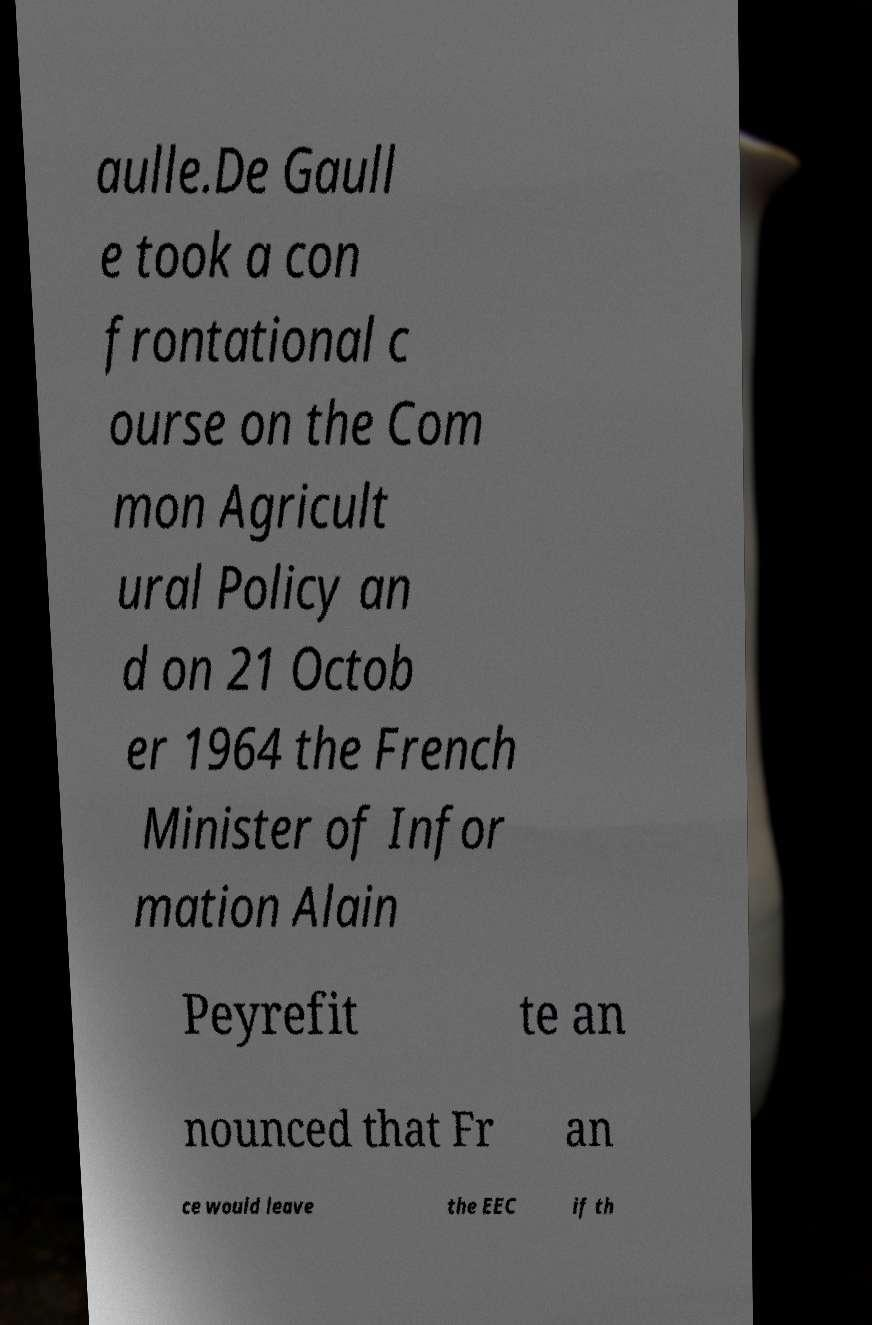I need the written content from this picture converted into text. Can you do that? aulle.De Gaull e took a con frontational c ourse on the Com mon Agricult ural Policy an d on 21 Octob er 1964 the French Minister of Infor mation Alain Peyrefit te an nounced that Fr an ce would leave the EEC if th 